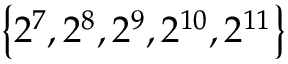Convert formula to latex. <formula><loc_0><loc_0><loc_500><loc_500>\left \{ 2 ^ { 7 } , 2 ^ { 8 } , 2 ^ { 9 } , 2 ^ { 1 0 } , 2 ^ { 1 1 } \right \}</formula> 